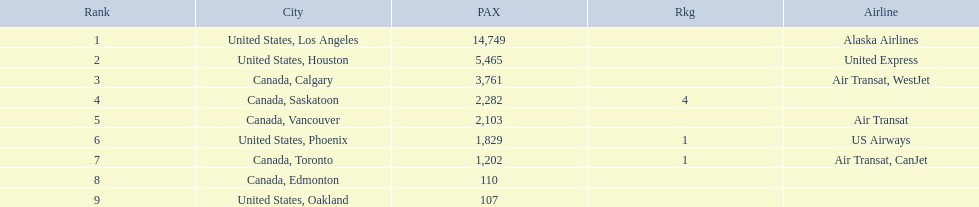Which cities had less than 2,000 passengers? United States, Phoenix, Canada, Toronto, Canada, Edmonton, United States, Oakland. Of these cities, which had fewer than 1,000 passengers? Canada, Edmonton, United States, Oakland. Of the cities in the previous answer, which one had only 107 passengers? United States, Oakland. 